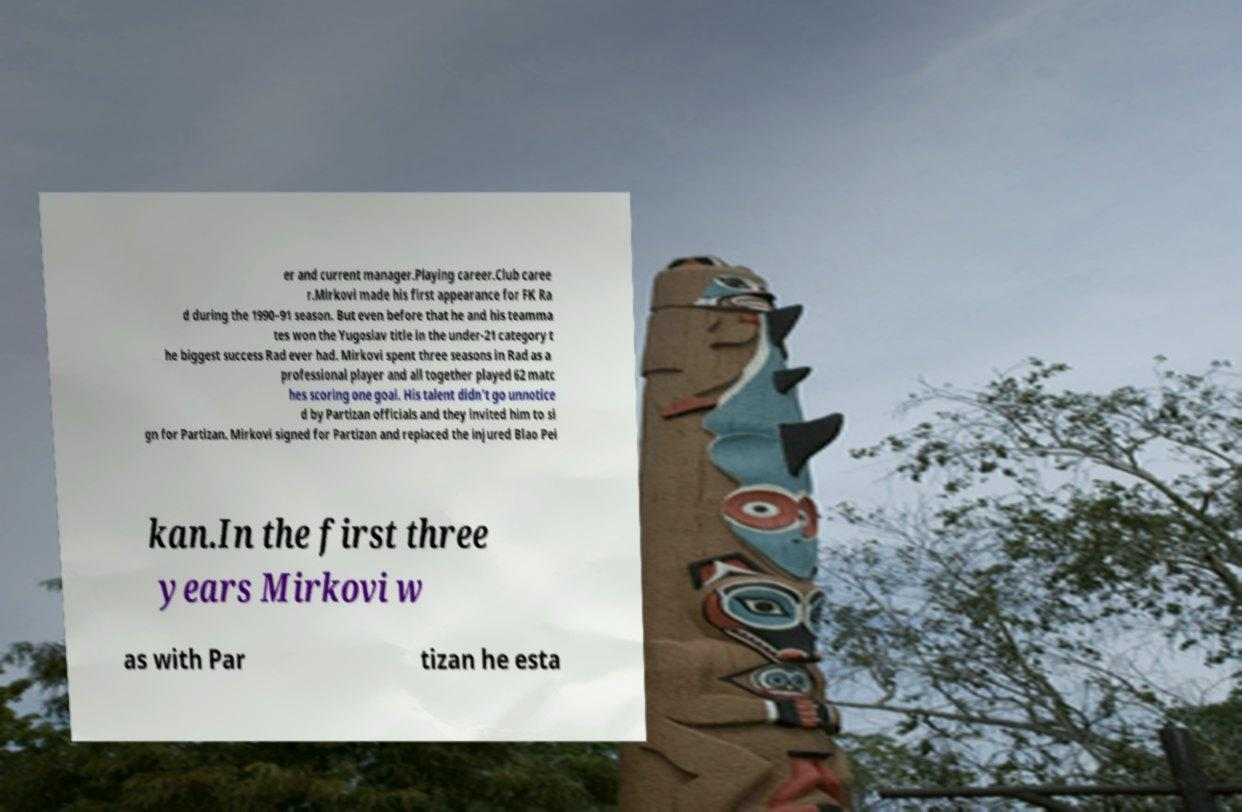Please read and relay the text visible in this image. What does it say? er and current manager.Playing career.Club caree r.Mirkovi made his first appearance for FK Ra d during the 1990–91 season. But even before that he and his teamma tes won the Yugoslav title in the under-21 category t he biggest success Rad ever had. Mirkovi spent three seasons in Rad as a professional player and all together played 62 matc hes scoring one goal. His talent didn't go unnotice d by Partizan officials and they invited him to si gn for Partizan. Mirkovi signed for Partizan and replaced the injured Blao Pei kan.In the first three years Mirkovi w as with Par tizan he esta 